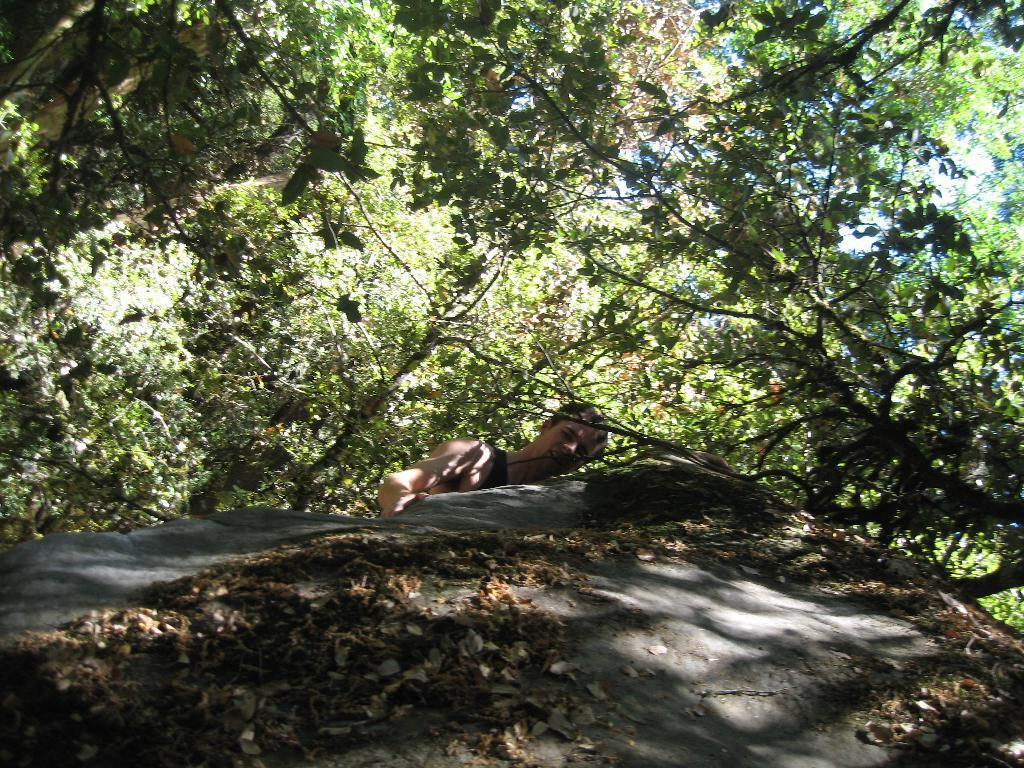What is the main object in the picture? There is a rock in the picture. Is there anyone near the rock? Yes, there is a man standing near the rock. What else can be seen in the picture besides the rock and the man? There are trees in the picture. Are there any leaves on the rock? Yes, there are leaves on the rock. How many chickens are sitting on the rock in the picture? There are no chickens present in the picture; it features a rock with leaves and a man standing nearby. What type of notebook is the man holding in the picture? There is no notebook visible in the picture; the man is standing near a rock with leaves. 